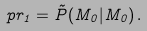Convert formula to latex. <formula><loc_0><loc_0><loc_500><loc_500>\ p r _ { 1 } = \tilde { P } ( M _ { 0 } | M _ { 0 } ) \, .</formula> 